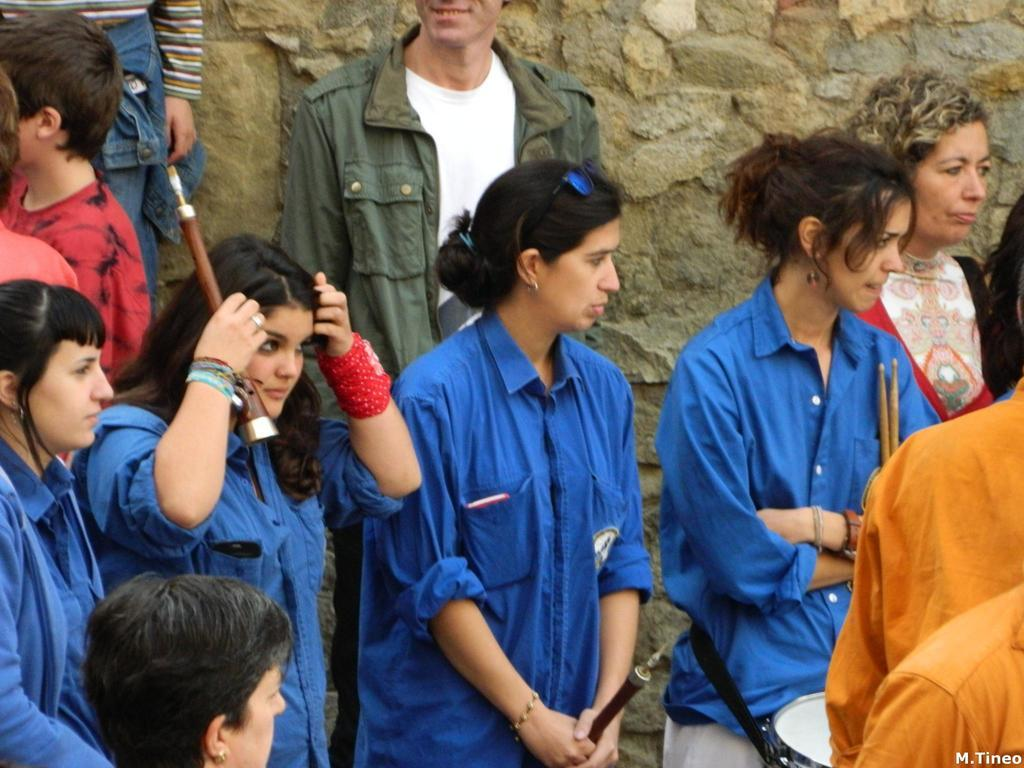What are the people in the image doing? The people in the image are walking on the road. What are the people carrying while walking? The people are carrying musical instruments. What type of oil can be seen dripping from the musical instruments in the image? There is no oil present in the image, and the musical instruments are not depicted as dripping anything. 